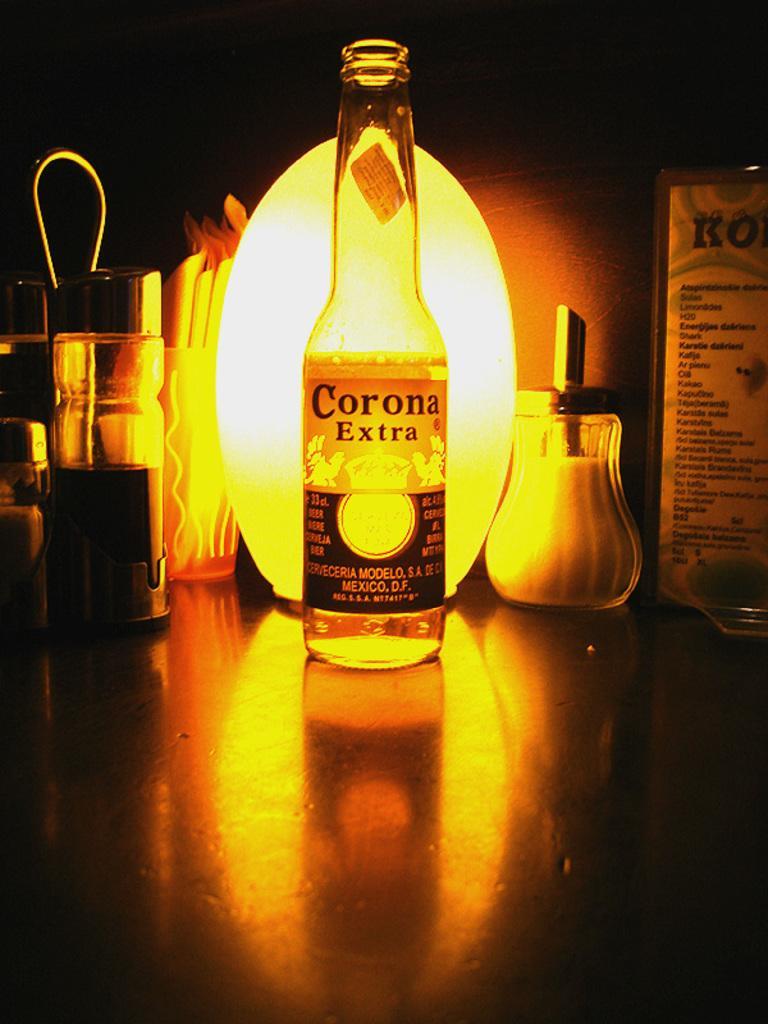Could you give a brief overview of what you see in this image? In this image, so many items are viewed. Bottle there is a sticker on it. Right side, there is a card. Left side, few containers. 